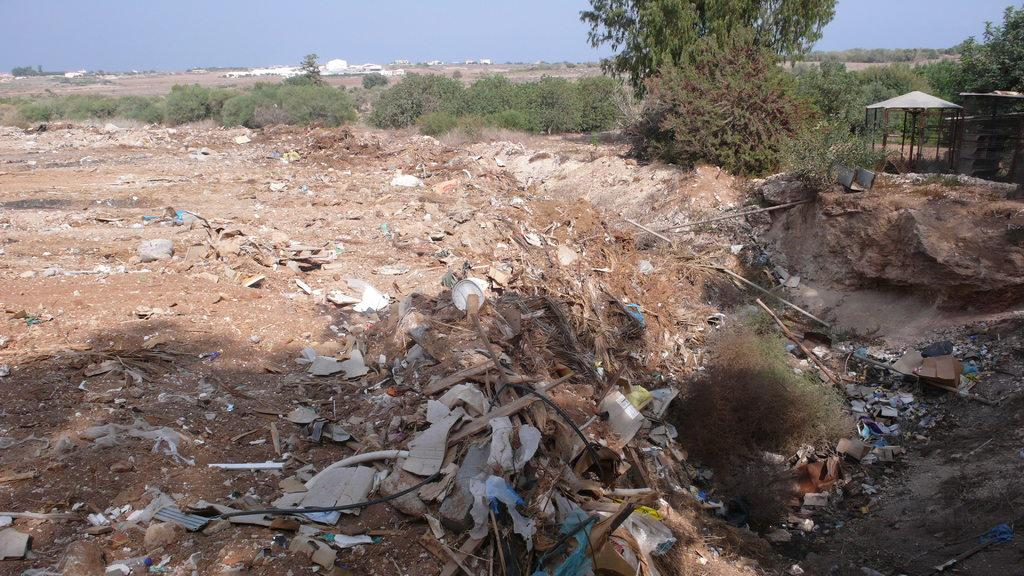What type of vegetation can be seen in the image? There are plants and trees in the image. What structures are present in the image? There are sheds in the image. What can be seen in the background of the image? There are buildings visible in the background of the image. How many pizzas are being prepared by the farmer in the image? There is no farmer or pizzas present in the image. 